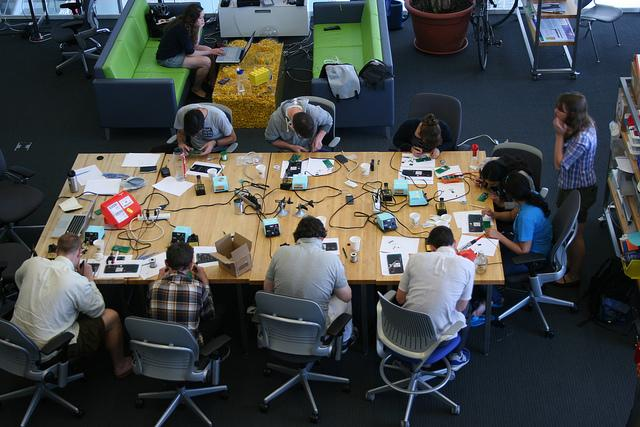What would soon stop here if there were a power outage? electronics 